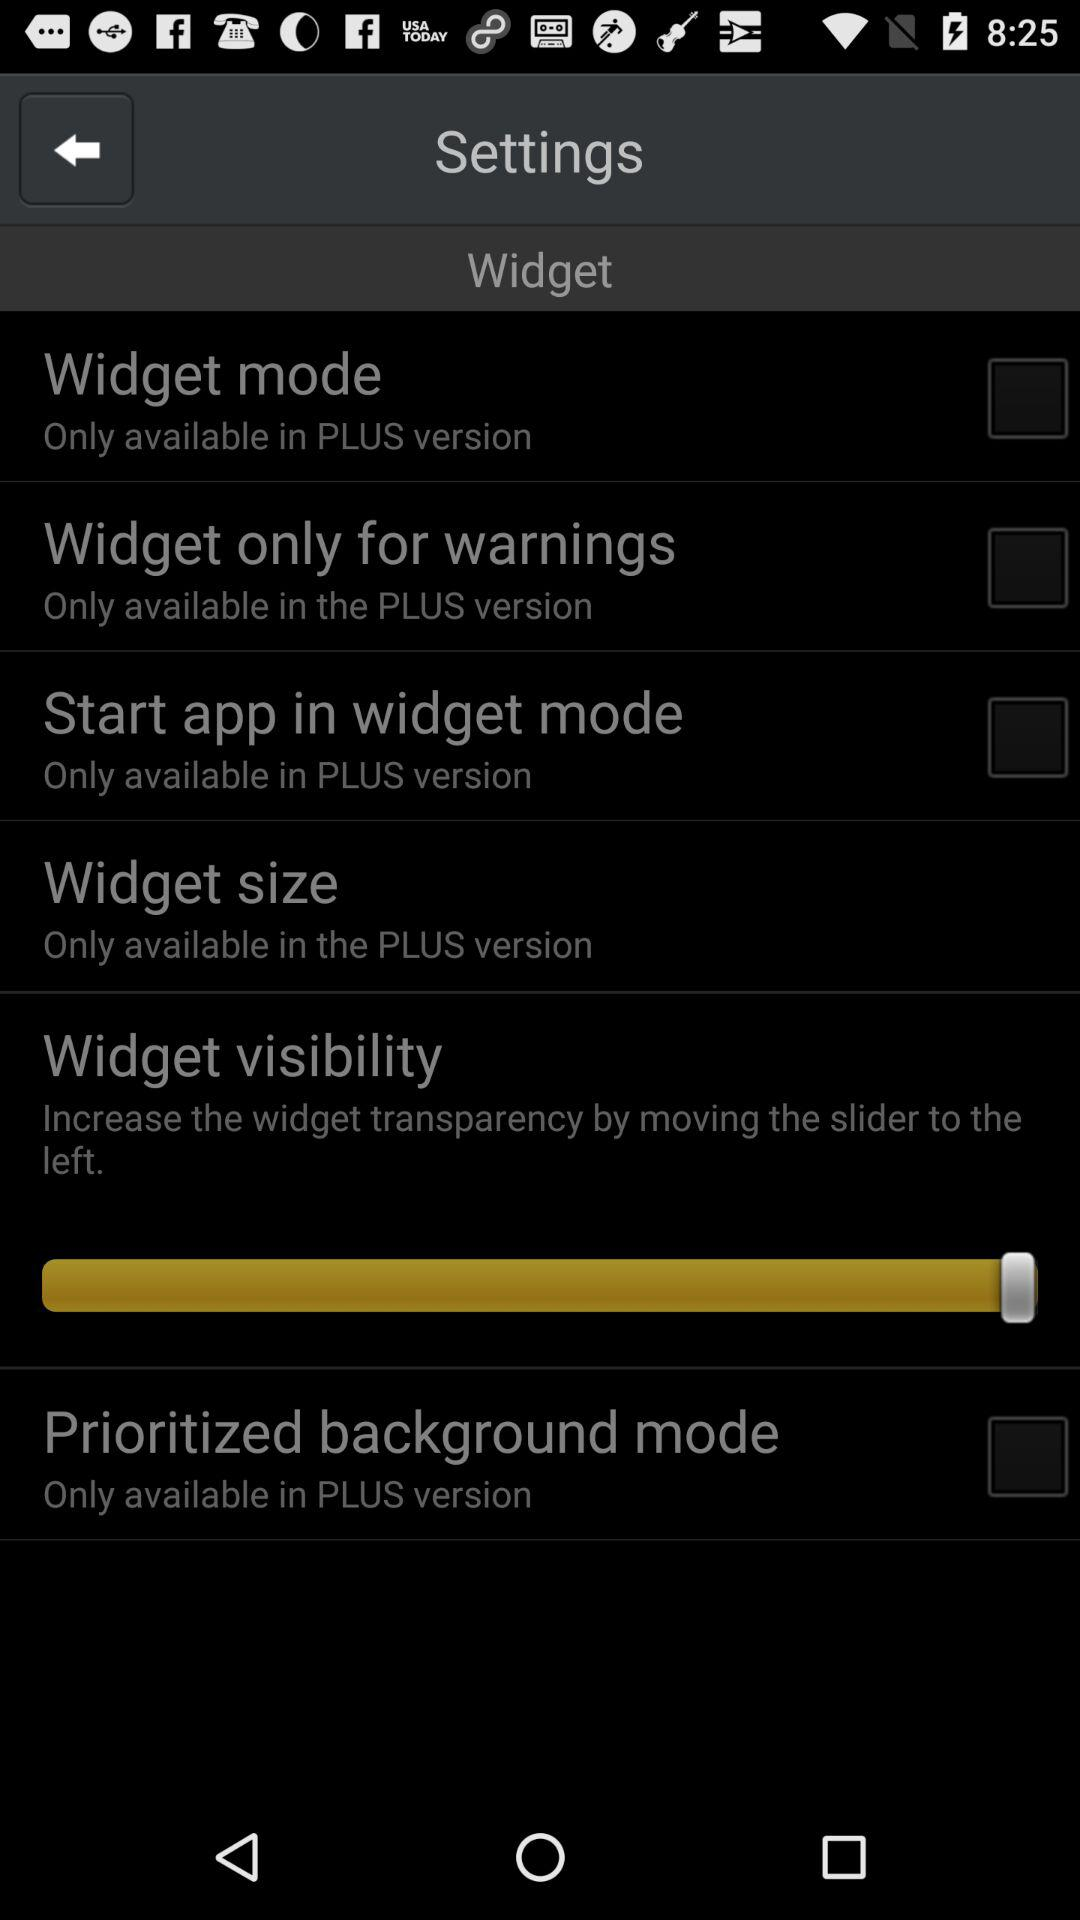In which version is the start app in widget mode only available? Start app in widget mode is only available in the PLUS version. 